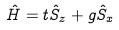Convert formula to latex. <formula><loc_0><loc_0><loc_500><loc_500>\hat { H } = t \hat { S } _ { z } + g \hat { S } _ { x }</formula> 